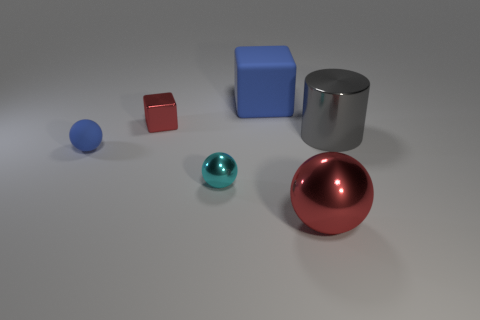What color is the rubber block that is the same size as the cylinder?
Ensure brevity in your answer.  Blue. Is there a large gray matte thing of the same shape as the big gray shiny object?
Keep it short and to the point. No. There is a block behind the tiny shiny object that is behind the rubber object in front of the large gray cylinder; what is its color?
Give a very brief answer. Blue. How many metallic things are either small cyan things or large red objects?
Offer a very short reply. 2. Are there more large things to the right of the rubber cube than small objects that are behind the metallic cylinder?
Offer a very short reply. Yes. What number of other objects are the same size as the gray cylinder?
Give a very brief answer. 2. What is the size of the red object behind the red metallic thing that is on the right side of the blue matte cube?
Make the answer very short. Small. What number of large objects are either red objects or metal cylinders?
Make the answer very short. 2. There is a blue rubber object that is behind the blue rubber thing that is in front of the cube that is to the left of the blue cube; what is its size?
Your answer should be compact. Large. Is there anything else that is the same color as the large cylinder?
Your answer should be compact. No. 